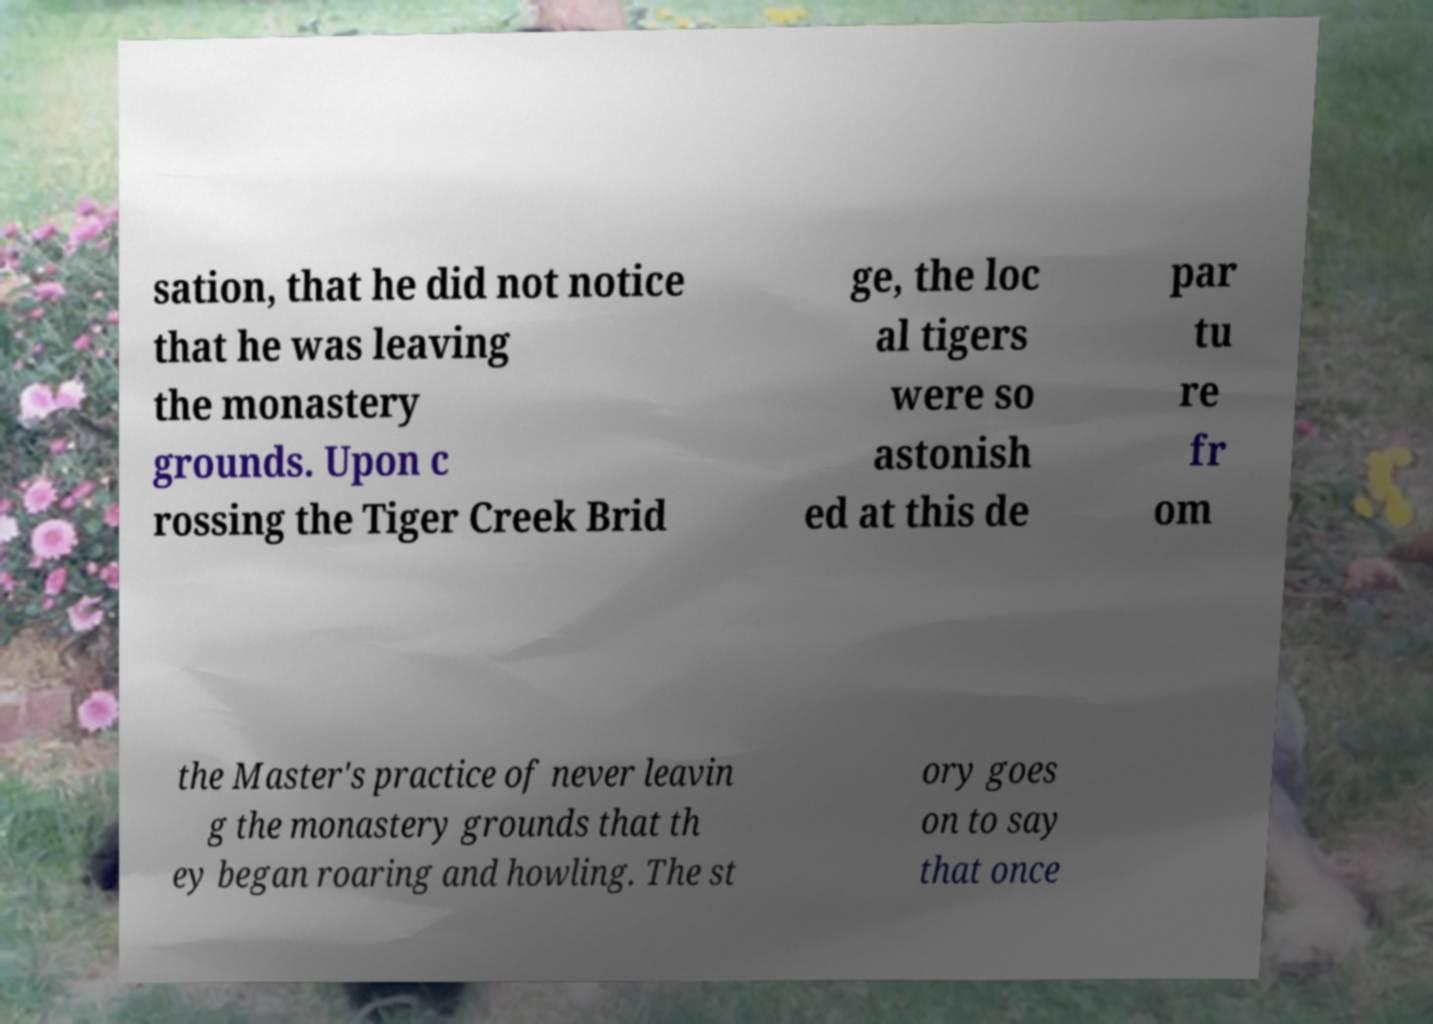There's text embedded in this image that I need extracted. Can you transcribe it verbatim? sation, that he did not notice that he was leaving the monastery grounds. Upon c rossing the Tiger Creek Brid ge, the loc al tigers were so astonish ed at this de par tu re fr om the Master's practice of never leavin g the monastery grounds that th ey began roaring and howling. The st ory goes on to say that once 